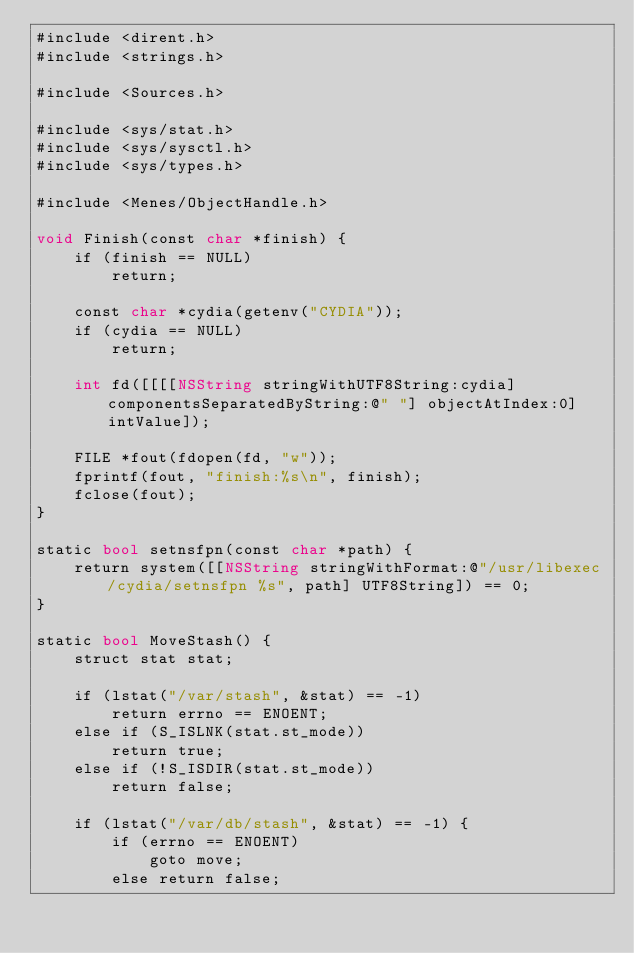Convert code to text. <code><loc_0><loc_0><loc_500><loc_500><_ObjectiveC_>#include <dirent.h>
#include <strings.h>

#include <Sources.h>

#include <sys/stat.h>
#include <sys/sysctl.h>
#include <sys/types.h>

#include <Menes/ObjectHandle.h>

void Finish(const char *finish) {
    if (finish == NULL)
        return;

    const char *cydia(getenv("CYDIA"));
    if (cydia == NULL)
        return;

    int fd([[[[NSString stringWithUTF8String:cydia] componentsSeparatedByString:@" "] objectAtIndex:0] intValue]);

    FILE *fout(fdopen(fd, "w"));
    fprintf(fout, "finish:%s\n", finish);
    fclose(fout);
}

static bool setnsfpn(const char *path) {
    return system([[NSString stringWithFormat:@"/usr/libexec/cydia/setnsfpn %s", path] UTF8String]) == 0;
}

static bool MoveStash() {
    struct stat stat;

    if (lstat("/var/stash", &stat) == -1)
        return errno == ENOENT;
    else if (S_ISLNK(stat.st_mode))
        return true;
    else if (!S_ISDIR(stat.st_mode))
        return false;

    if (lstat("/var/db/stash", &stat) == -1) {
        if (errno == ENOENT)
            goto move;
        else return false;</code> 